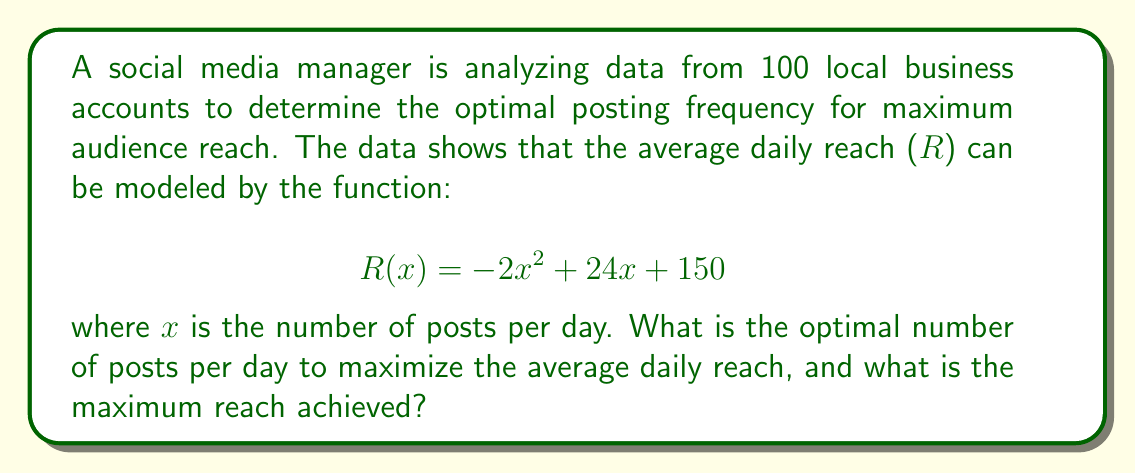Help me with this question. To solve this problem, we need to follow these steps:

1) The function $R(x) = -2x^2 + 24x + 150$ is a quadratic function, and its graph is a parabola that opens downward (because the coefficient of $x^2$ is negative).

2) To find the maximum value of a quadratic function, we need to find the vertex of the parabola. The x-coordinate of the vertex will give us the optimal number of posts, and the y-coordinate will give us the maximum reach.

3) For a quadratic function in the form $f(x) = ax^2 + bx + c$, the x-coordinate of the vertex is given by $x = -\frac{b}{2a}$.

4) In our case, $a = -2$, $b = 24$, and $c = 150$. Let's substitute these values:

   $$x = -\frac{24}{2(-2)} = -\frac{24}{-4} = 6$$

5) This means the optimal number of posts is 6 per day.

6) To find the maximum reach, we need to calculate $R(6)$:

   $$\begin{align}
   R(6) &= -2(6)^2 + 24(6) + 150 \\
        &= -2(36) + 144 + 150 \\
        &= -72 + 144 + 150 \\
        &= 222
   \end{align}$$

Therefore, the maximum average daily reach is 222.
Answer: The optimal number of posts per day is 6, and the maximum average daily reach achieved is 222. 